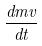<formula> <loc_0><loc_0><loc_500><loc_500>\frac { d m v } { d t }</formula> 